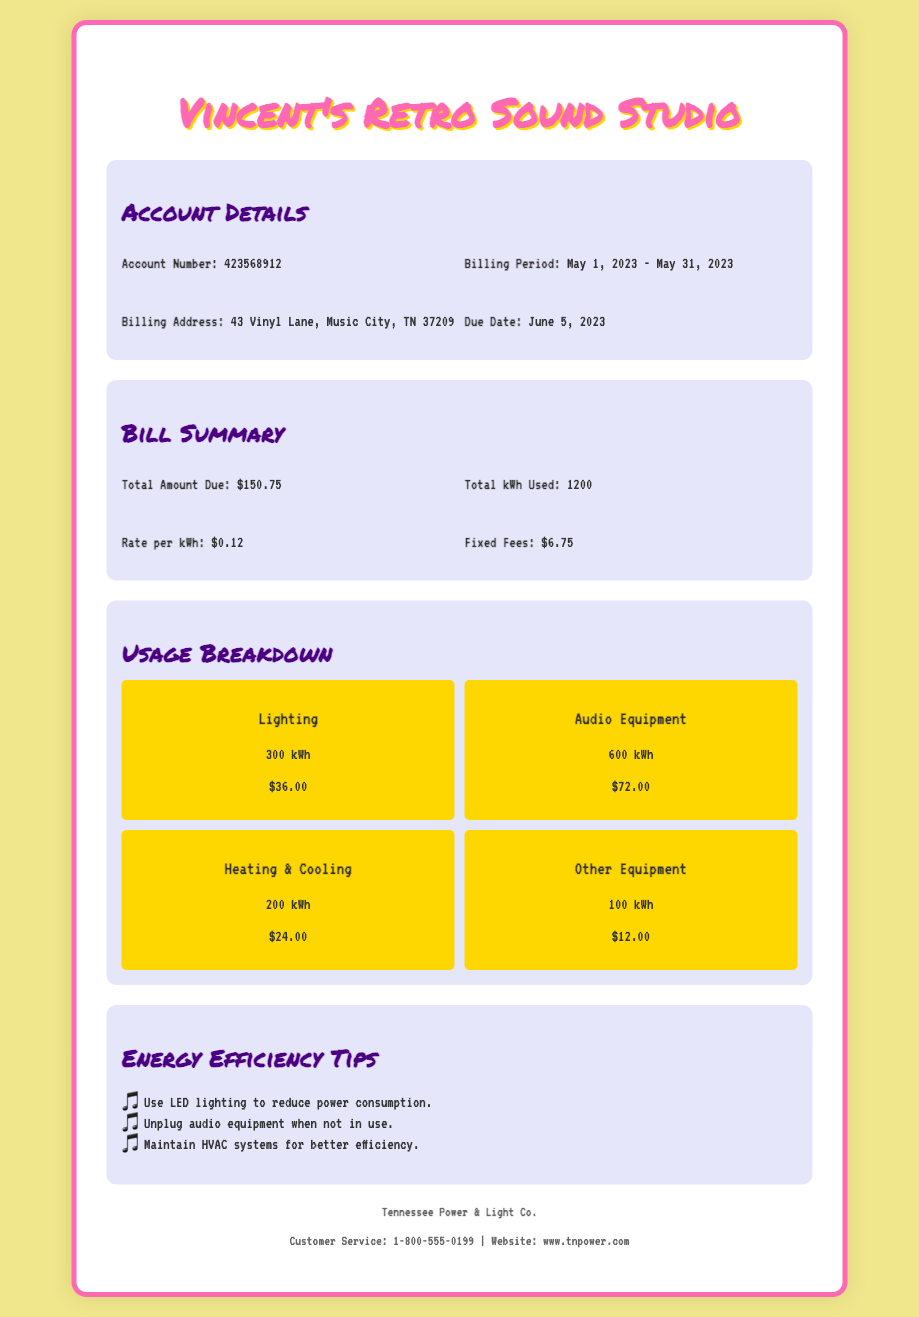What is the account number? The account number is listed in the account details section of the document.
Answer: 423568912 What is the billing period? The billing period specifies the dates for which the bill is applicable.
Answer: May 1, 2023 - May 31, 2023 How much is the total amount due? The total amount due is highlighted in the bill summary section.
Answer: $150.75 What is the rate per kWh? The rate per kWh is detailed in the bill summary.
Answer: $0.12 How many kWh were used for audio equipment? The usage for audio equipment is specified in the usage breakdown section.
Answer: 600 kWh What is the fixed fee amount? The fixed fees are listed in the bill summary section of the document.
Answer: $6.75 What is the usage for heating and cooling? The usage for heating and cooling is included in the usage breakdown.
Answer: 200 kWh What is one energy efficiency tip provided? The document lists several tips for energy efficiency under a specific section.
Answer: Use LED lighting to reduce power consumption What is the due date for the bill? The due date for payment is mentioned in the account details section.
Answer: June 5, 2023 